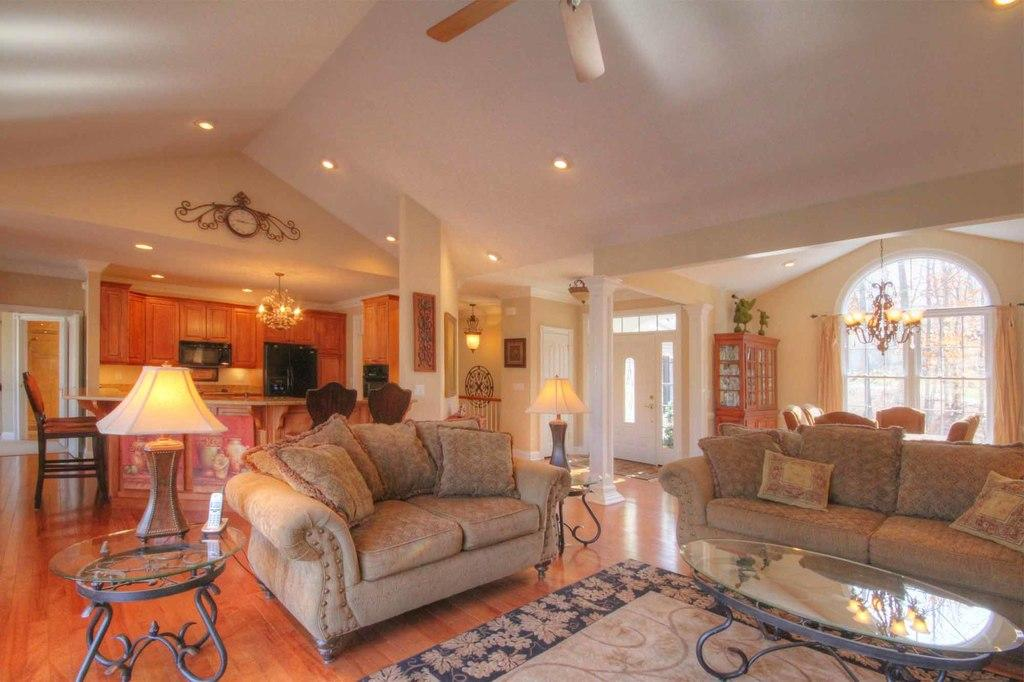What type of space is depicted in the image? The image shows an inner view of a house. What type of furniture can be seen in the image? There is a sofa in the image. What type of lighting is present in the image? There is a lamp in the image. What type of appliance is present in the image? There is a ceiling fan in the image. What type of surface is present in the image? There is a table in the image. Can you see a bird flying around in the image? There is no bird present in the image. Is there a gun visible on the table in the image? There is no gun present in the image. 